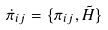<formula> <loc_0><loc_0><loc_500><loc_500>\dot { \pi } _ { i j } = \{ \pi _ { i j } , \tilde { H } \}</formula> 